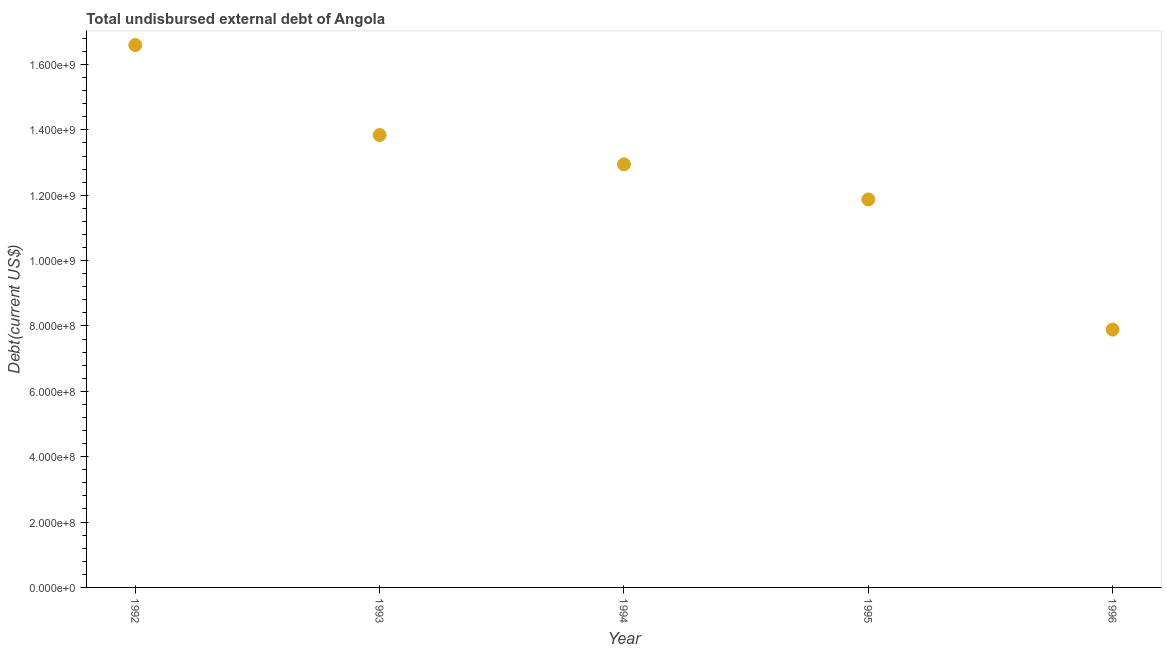What is the total debt in 1993?
Offer a very short reply. 1.38e+09. Across all years, what is the maximum total debt?
Provide a succinct answer. 1.66e+09. Across all years, what is the minimum total debt?
Your response must be concise. 7.89e+08. In which year was the total debt minimum?
Offer a terse response. 1996. What is the sum of the total debt?
Make the answer very short. 6.31e+09. What is the difference between the total debt in 1994 and 1996?
Your answer should be compact. 5.06e+08. What is the average total debt per year?
Give a very brief answer. 1.26e+09. What is the median total debt?
Offer a terse response. 1.29e+09. In how many years, is the total debt greater than 320000000 US$?
Provide a short and direct response. 5. What is the ratio of the total debt in 1992 to that in 1995?
Give a very brief answer. 1.4. What is the difference between the highest and the second highest total debt?
Provide a succinct answer. 2.75e+08. What is the difference between the highest and the lowest total debt?
Provide a short and direct response. 8.71e+08. In how many years, is the total debt greater than the average total debt taken over all years?
Offer a terse response. 3. How many years are there in the graph?
Offer a terse response. 5. Are the values on the major ticks of Y-axis written in scientific E-notation?
Keep it short and to the point. Yes. Does the graph contain grids?
Make the answer very short. No. What is the title of the graph?
Your answer should be compact. Total undisbursed external debt of Angola. What is the label or title of the X-axis?
Ensure brevity in your answer.  Year. What is the label or title of the Y-axis?
Your answer should be compact. Debt(current US$). What is the Debt(current US$) in 1992?
Give a very brief answer. 1.66e+09. What is the Debt(current US$) in 1993?
Offer a terse response. 1.38e+09. What is the Debt(current US$) in 1994?
Offer a terse response. 1.29e+09. What is the Debt(current US$) in 1995?
Ensure brevity in your answer.  1.19e+09. What is the Debt(current US$) in 1996?
Ensure brevity in your answer.  7.89e+08. What is the difference between the Debt(current US$) in 1992 and 1993?
Provide a short and direct response. 2.75e+08. What is the difference between the Debt(current US$) in 1992 and 1994?
Your response must be concise. 3.65e+08. What is the difference between the Debt(current US$) in 1992 and 1995?
Ensure brevity in your answer.  4.72e+08. What is the difference between the Debt(current US$) in 1992 and 1996?
Keep it short and to the point. 8.71e+08. What is the difference between the Debt(current US$) in 1993 and 1994?
Give a very brief answer. 8.97e+07. What is the difference between the Debt(current US$) in 1993 and 1995?
Provide a succinct answer. 1.97e+08. What is the difference between the Debt(current US$) in 1993 and 1996?
Make the answer very short. 5.95e+08. What is the difference between the Debt(current US$) in 1994 and 1995?
Offer a very short reply. 1.07e+08. What is the difference between the Debt(current US$) in 1994 and 1996?
Offer a very short reply. 5.06e+08. What is the difference between the Debt(current US$) in 1995 and 1996?
Provide a short and direct response. 3.98e+08. What is the ratio of the Debt(current US$) in 1992 to that in 1993?
Offer a very short reply. 1.2. What is the ratio of the Debt(current US$) in 1992 to that in 1994?
Give a very brief answer. 1.28. What is the ratio of the Debt(current US$) in 1992 to that in 1995?
Keep it short and to the point. 1.4. What is the ratio of the Debt(current US$) in 1992 to that in 1996?
Your response must be concise. 2.1. What is the ratio of the Debt(current US$) in 1993 to that in 1994?
Provide a succinct answer. 1.07. What is the ratio of the Debt(current US$) in 1993 to that in 1995?
Provide a succinct answer. 1.17. What is the ratio of the Debt(current US$) in 1993 to that in 1996?
Keep it short and to the point. 1.75. What is the ratio of the Debt(current US$) in 1994 to that in 1995?
Offer a very short reply. 1.09. What is the ratio of the Debt(current US$) in 1994 to that in 1996?
Your response must be concise. 1.64. What is the ratio of the Debt(current US$) in 1995 to that in 1996?
Make the answer very short. 1.5. 